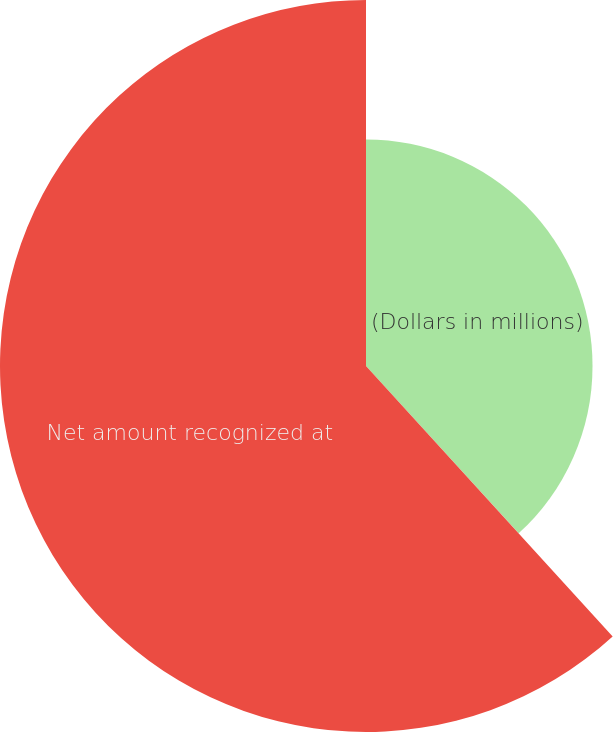<chart> <loc_0><loc_0><loc_500><loc_500><pie_chart><fcel>(Dollars in millions)<fcel>Net amount recognized at<nl><fcel>38.23%<fcel>61.77%<nl></chart> 